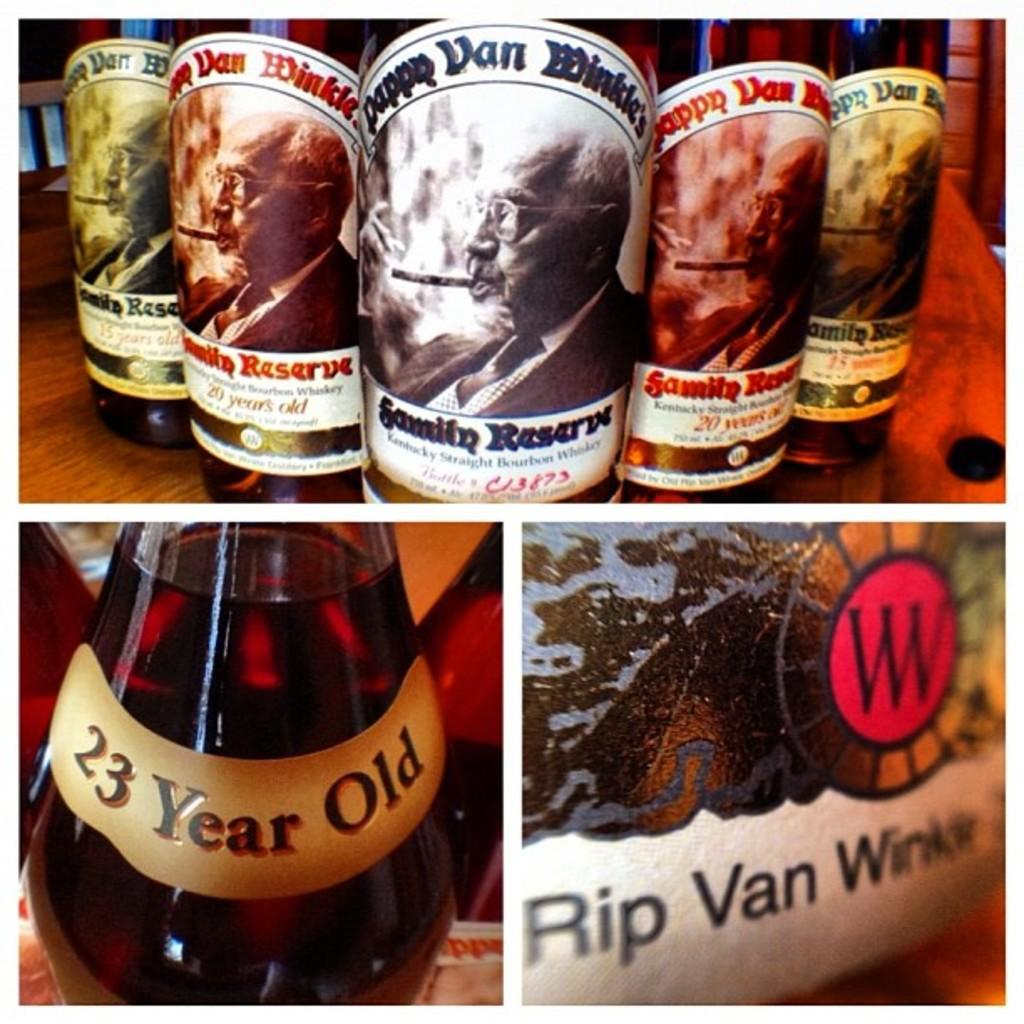<image>
Offer a succinct explanation of the picture presented. A selection of Pappy Van Winkle whiskey bottles. 